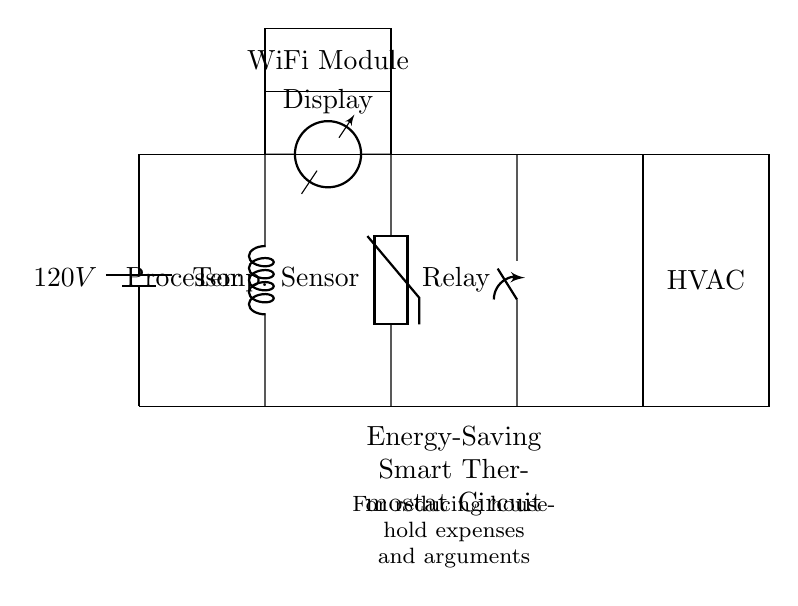What is the main power supply voltage? The main power supply in the circuit is labeled as 120V. This is directly indicated at the source component which is a battery in the circuit diagram.
Answer: 120V What component controls the HVAC system? The relay is the component that controls the HVAC system. It is connected to the thermostat control unit and allows the HVAC to be turned on or off based on the thermostat's readings.
Answer: Relay How does the thermostat unit communicate with the HVAC system? The thermostat unit uses a relay to communicate with the HVAC system. The relay acts as a switch that is activated by the thermostat’s control unit, thus turning the HVAC system on or off according to the temperature requirements.
Answer: Through Relay What is the role of the WiFi module in this circuit? The WiFi module enables the smart thermostat to connect to a network, allowing for remote monitoring and control via a smartphone or other devices. It links the thermostat to the internet for improved energy management.
Answer: Remote communication Which component senses the temperature in the circuit? The temperature sensor, specifically a thermistor, is responsible for sensing the ambient temperature. This component feeds temperature data to the thermostat control unit for decision-making regarding HVAC operations.
Answer: Temperature Sensor How many main components are in the circuit? By counting the components in the diagram, we have the main power supply, thermostat control unit, display, temperature sensor, relay, HVAC system, and WiFi module, totaling seven primary components.
Answer: Seven 